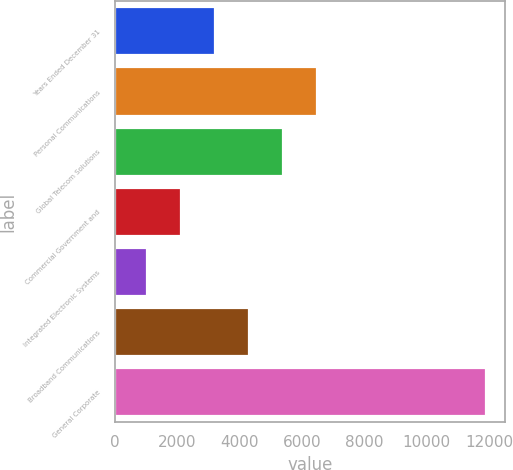Convert chart to OTSL. <chart><loc_0><loc_0><loc_500><loc_500><bar_chart><fcel>Years Ended December 31<fcel>Personal Communications<fcel>Global Telecom Solutions<fcel>Commercial Government and<fcel>Integrated Electronic Systems<fcel>Broadband Communications<fcel>General Corporate<nl><fcel>3206<fcel>6467<fcel>5380<fcel>2119<fcel>1032<fcel>4293<fcel>11902<nl></chart> 